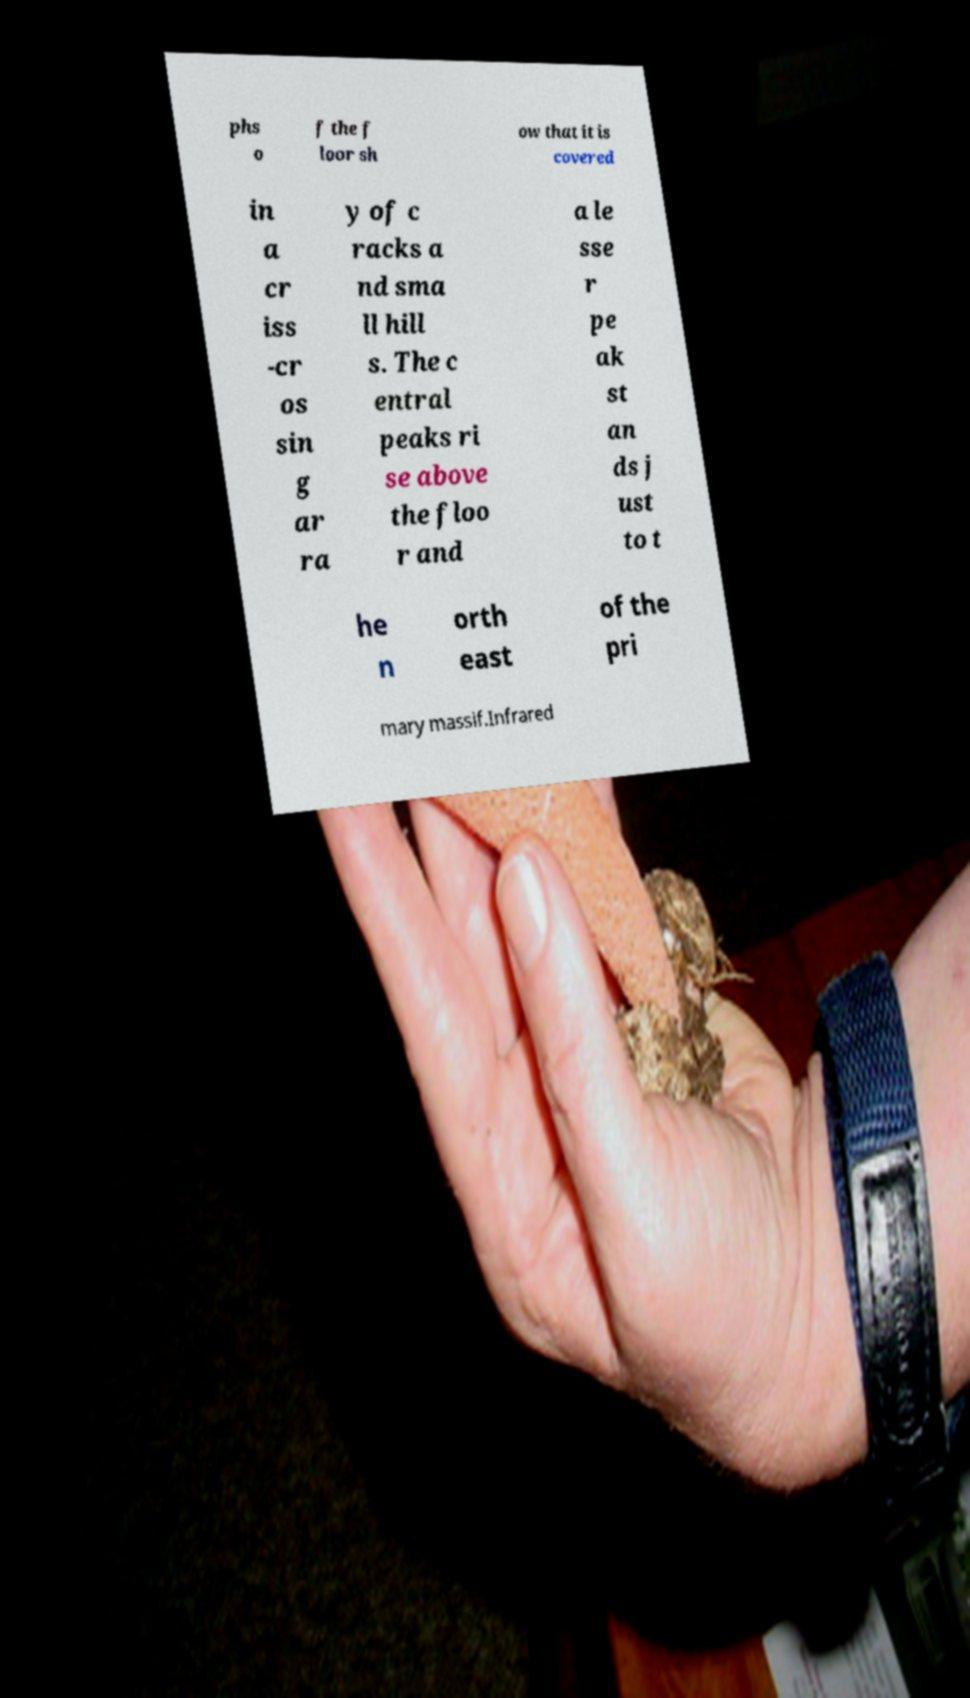I need the written content from this picture converted into text. Can you do that? phs o f the f loor sh ow that it is covered in a cr iss -cr os sin g ar ra y of c racks a nd sma ll hill s. The c entral peaks ri se above the floo r and a le sse r pe ak st an ds j ust to t he n orth east of the pri mary massif.Infrared 